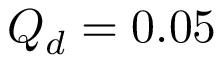Convert formula to latex. <formula><loc_0><loc_0><loc_500><loc_500>Q _ { d } = 0 . 0 5</formula> 